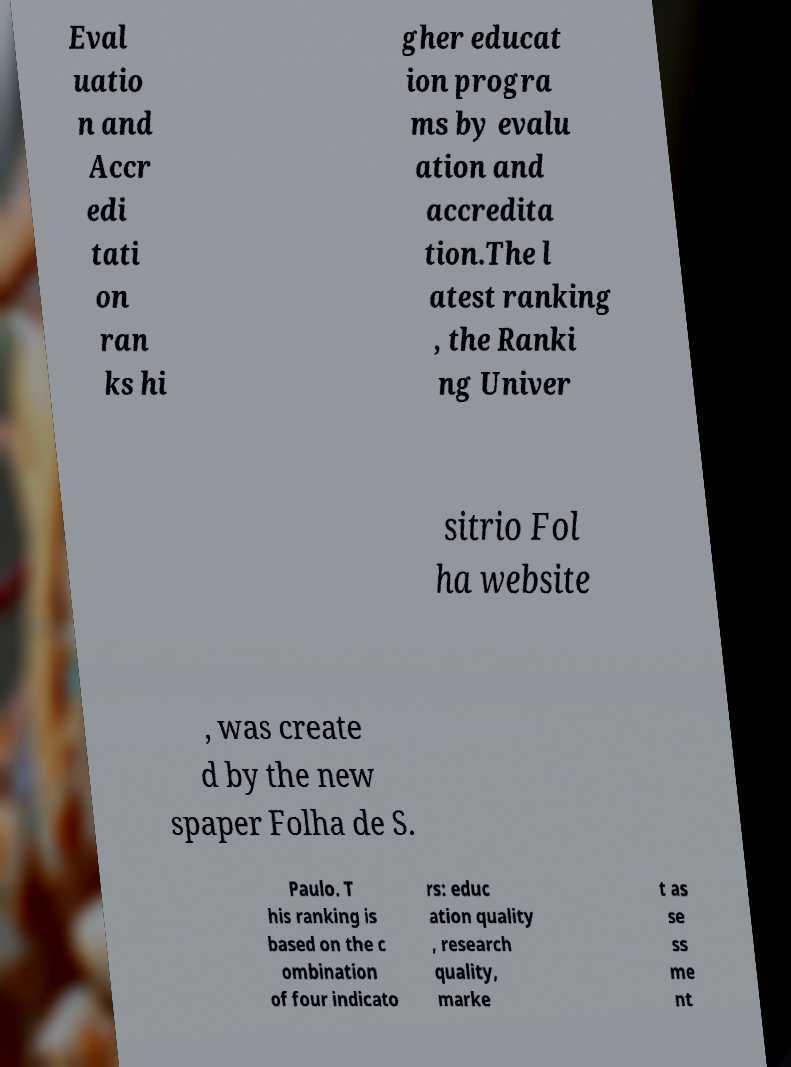What messages or text are displayed in this image? I need them in a readable, typed format. Eval uatio n and Accr edi tati on ran ks hi gher educat ion progra ms by evalu ation and accredita tion.The l atest ranking , the Ranki ng Univer sitrio Fol ha website , was create d by the new spaper Folha de S. Paulo. T his ranking is based on the c ombination of four indicato rs: educ ation quality , research quality, marke t as se ss me nt 